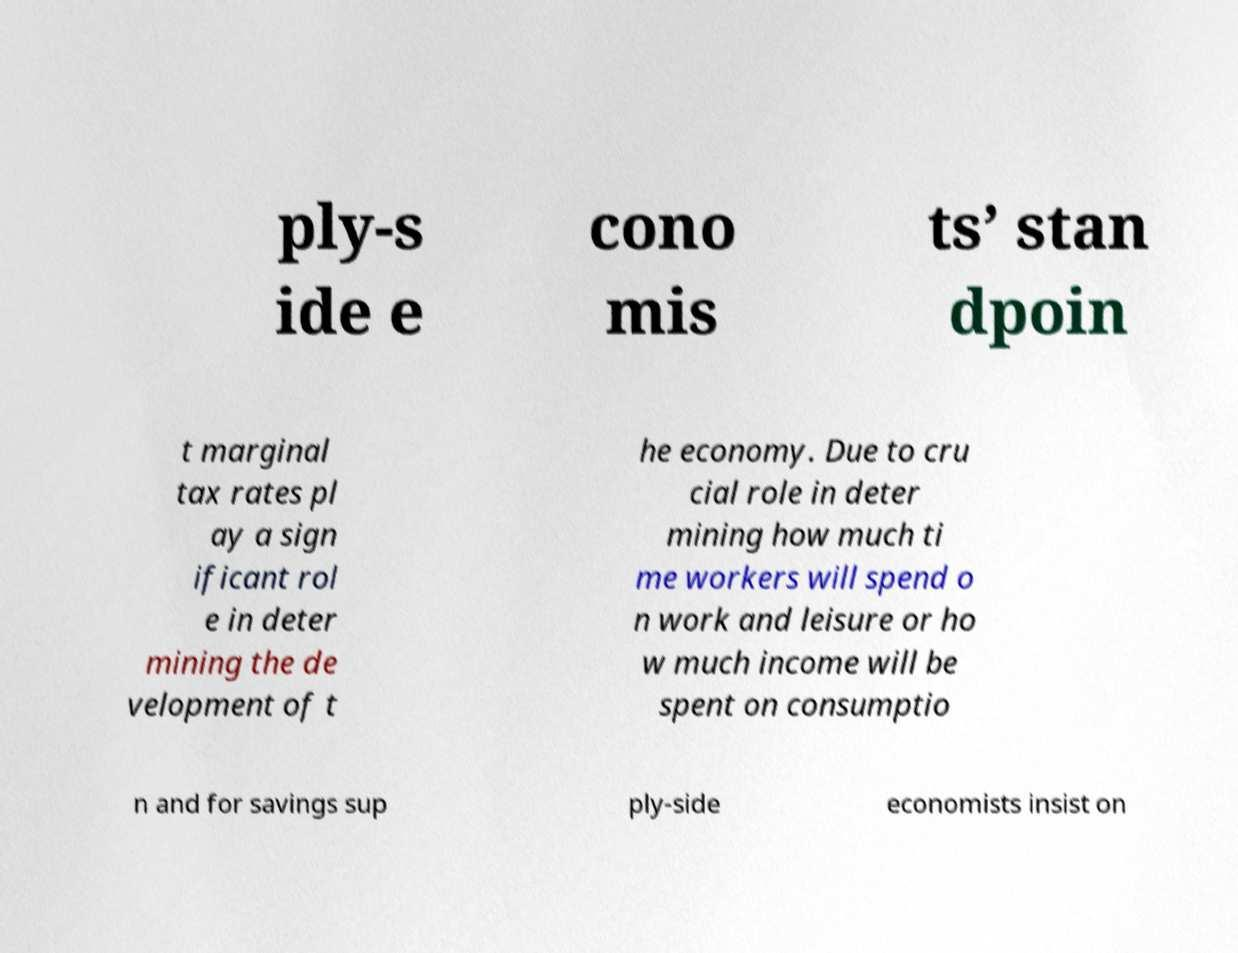I need the written content from this picture converted into text. Can you do that? ply-s ide e cono mis ts’ stan dpoin t marginal tax rates pl ay a sign ificant rol e in deter mining the de velopment of t he economy. Due to cru cial role in deter mining how much ti me workers will spend o n work and leisure or ho w much income will be spent on consumptio n and for savings sup ply-side economists insist on 